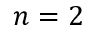<formula> <loc_0><loc_0><loc_500><loc_500>n = 2</formula> 